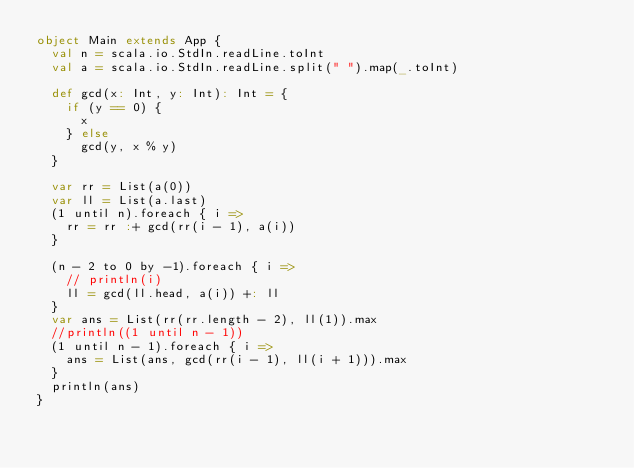<code> <loc_0><loc_0><loc_500><loc_500><_Scala_>object Main extends App {
  val n = scala.io.StdIn.readLine.toInt
  val a = scala.io.StdIn.readLine.split(" ").map(_.toInt)

  def gcd(x: Int, y: Int): Int = {
    if (y == 0) {
      x
    } else
      gcd(y, x % y)
  }

  var rr = List(a(0))
  var ll = List(a.last)
  (1 until n).foreach { i =>
    rr = rr :+ gcd(rr(i - 1), a(i))
  }

  (n - 2 to 0 by -1).foreach { i =>
    // println(i)
    ll = gcd(ll.head, a(i)) +: ll
  }
  var ans = List(rr(rr.length - 2), ll(1)).max
  //println((1 until n - 1))
  (1 until n - 1).foreach { i =>
    ans = List(ans, gcd(rr(i - 1), ll(i + 1))).max
  }
  println(ans)
}
</code> 